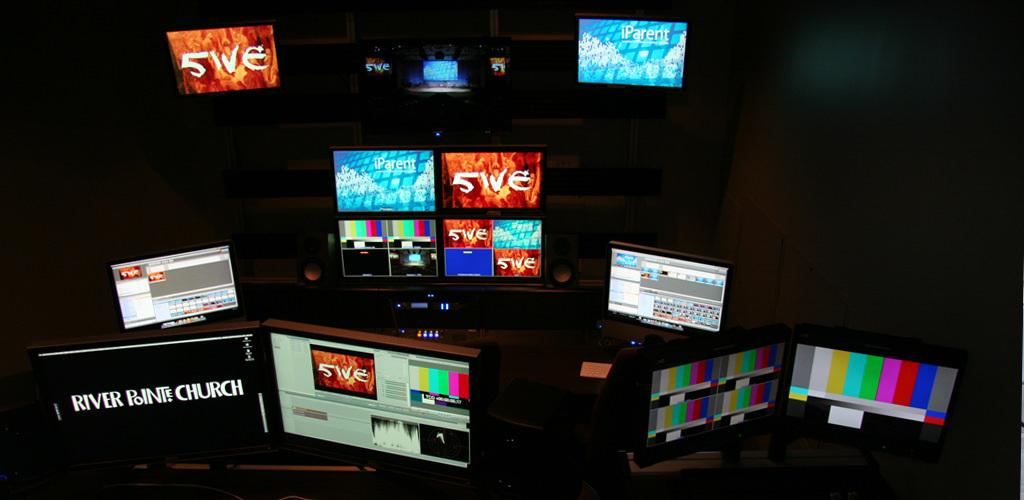Provide a one-sentence caption for the provided image. The name River Pointe Church is displayed on a monitor sitting amongst a group of other monitors. 